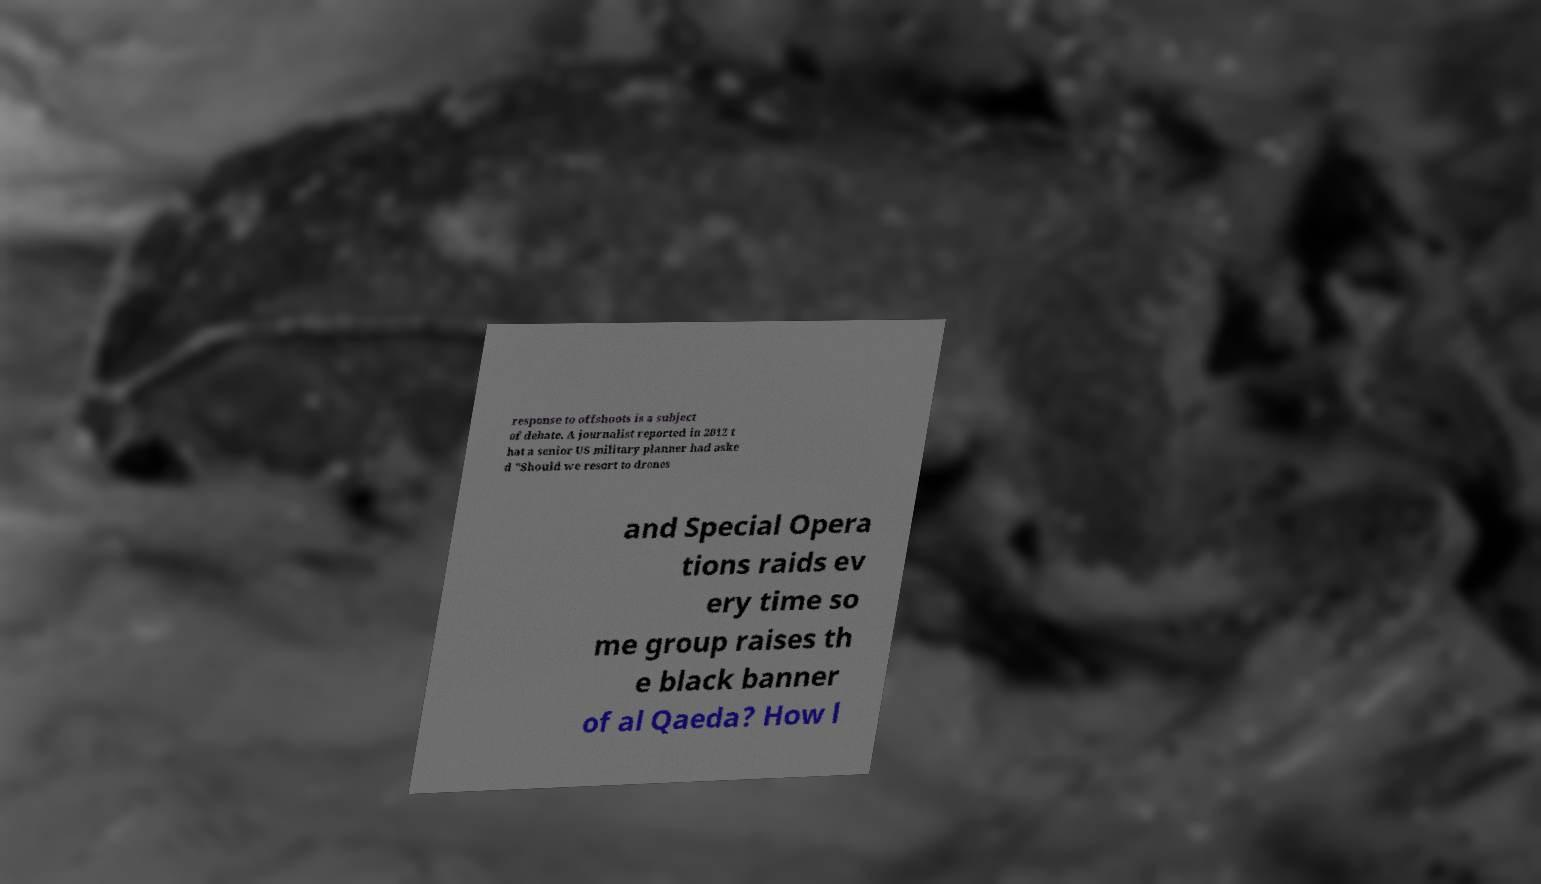Can you accurately transcribe the text from the provided image for me? response to offshoots is a subject of debate. A journalist reported in 2012 t hat a senior US military planner had aske d "Should we resort to drones and Special Opera tions raids ev ery time so me group raises th e black banner of al Qaeda? How l 